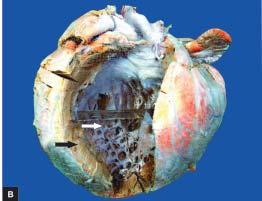what is heavier?
Answer the question using a single word or phrase. Heart 